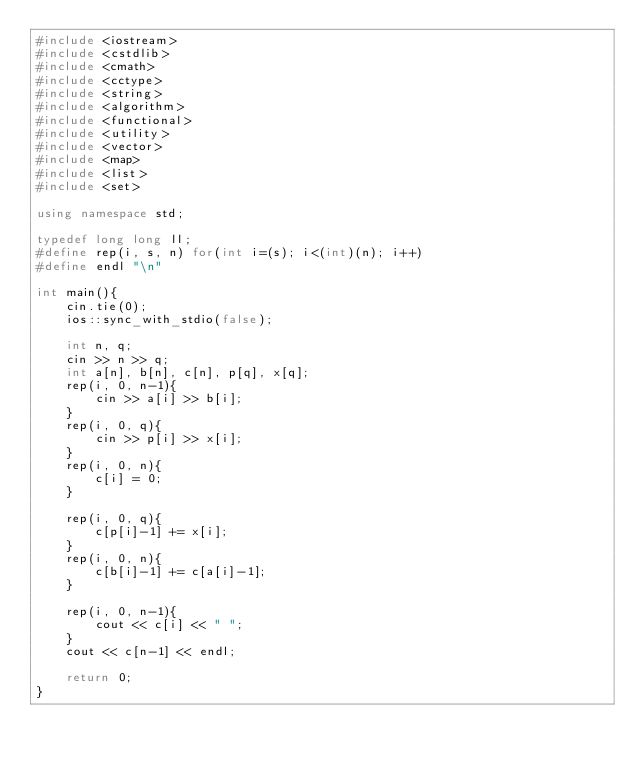<code> <loc_0><loc_0><loc_500><loc_500><_C++_>#include <iostream>
#include <cstdlib>
#include <cmath>
#include <cctype>
#include <string>
#include <algorithm>
#include <functional>
#include <utility>
#include <vector>
#include <map>
#include <list>
#include <set>

using namespace std;

typedef long long ll;
#define rep(i, s, n) for(int i=(s); i<(int)(n); i++)
#define endl "\n"

int main(){
    cin.tie(0);
    ios::sync_with_stdio(false);

    int n, q;
    cin >> n >> q;
    int a[n], b[n], c[n], p[q], x[q];
    rep(i, 0, n-1){
        cin >> a[i] >> b[i];
    }
    rep(i, 0, q){
        cin >> p[i] >> x[i];
    }
    rep(i, 0, n){
        c[i] = 0;
    }

    rep(i, 0, q){
        c[p[i]-1] += x[i];
    }
    rep(i, 0, n){
        c[b[i]-1] += c[a[i]-1];
    }

    rep(i, 0, n-1){
        cout << c[i] << " ";
    }
    cout << c[n-1] << endl;

    return 0;
}</code> 